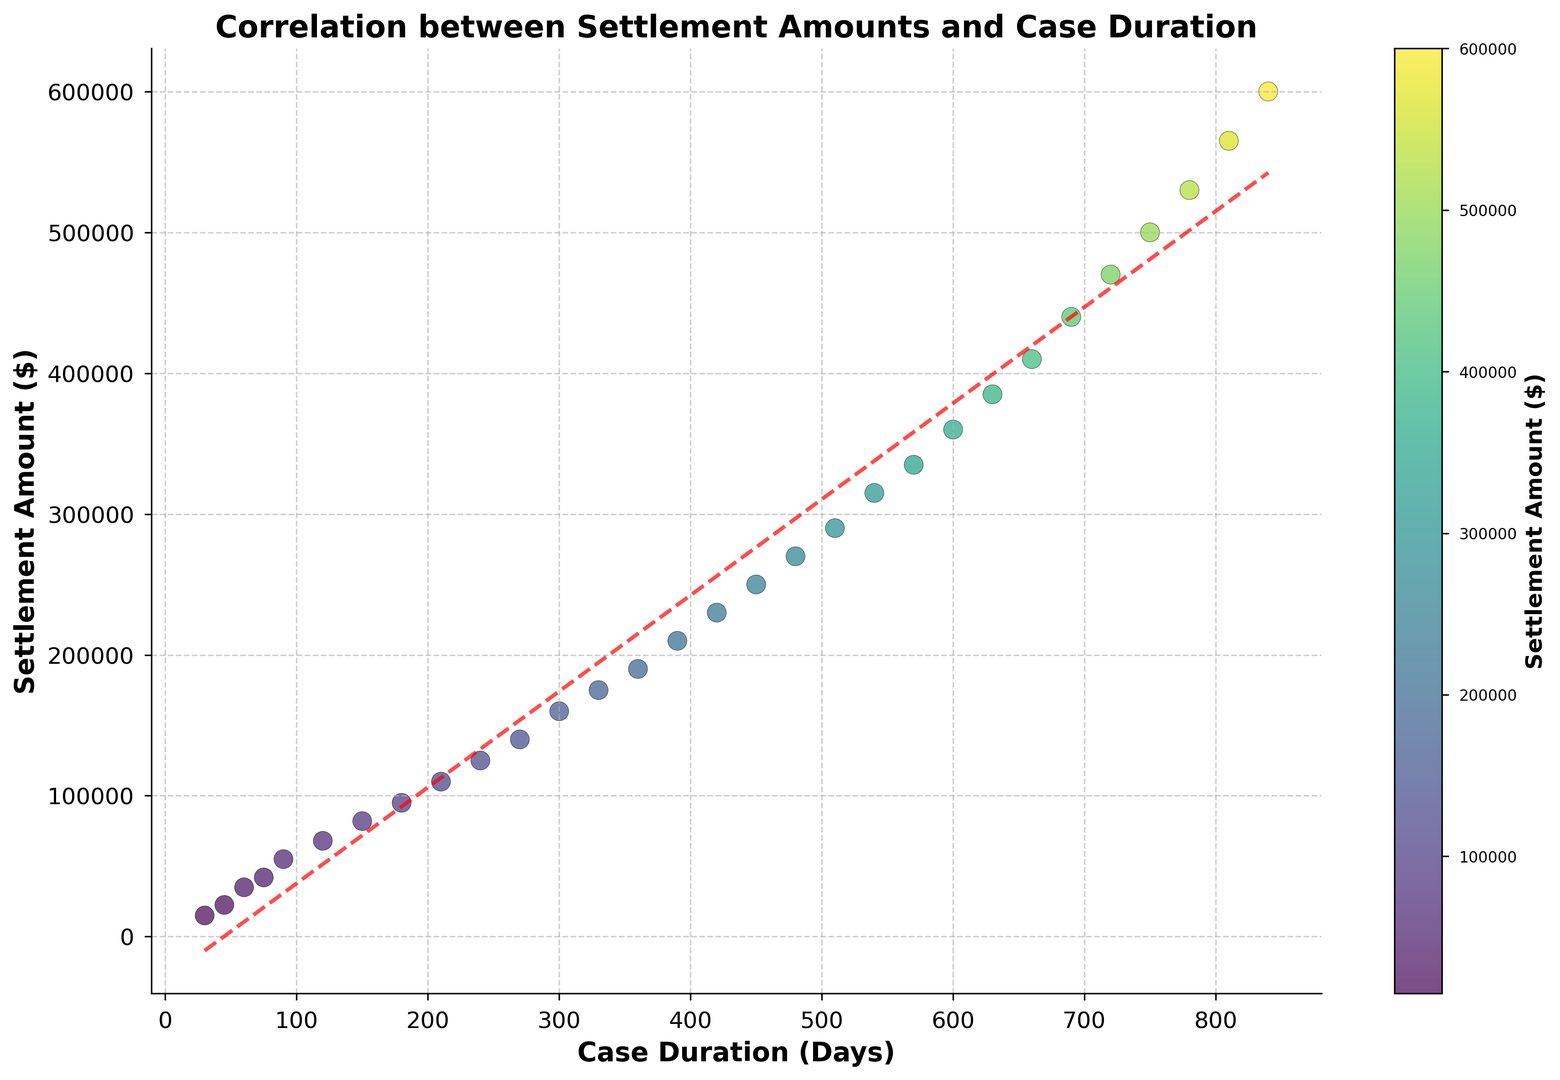What is the general trend shown by the scatter plot? The scatter plot shows a positive correlation between case duration and settlement amount; as the number of days increases, the settlement amount generally increases.
Answer: Positive correlation Which case duration had the highest settlement amount? Find the highest point on the y-axis, then refer to the corresponding x-axis value. The point at $600,000 corresponds to 840 days.
Answer: 840 days How does the settlement amount change as case duration moves from 180 days to 210 days? Compare the y-values at 180 days and 210 days. At 180 days, the amount is $95,000; at 210 days, it is $110,000. The settlement amount increases by $15,000.
Answer: Increases by $15,000 What is the average settlement amount for case durations greater than 500 days? Identify the points where the case duration is greater than 500 days, sum their settlement amounts, then divide by the number of points. The relevant points are (540, 315000), (570, 335000), (600, 360000), (630, 385000), (660, 410000), (690, 440000), (720, 470000), (750, 500000), (780, 530000), (810, 565000), (840, 600000). The sum is 4710000. The number of points is 11. So, the average is 4710000 / 11 = 428181.82.
Answer: $428,181.82 Is there a settlement amount for which two different case durations have the same value? Check for repeat y-values in the scatter plot. There are no pairs of different x-values corresponding to the same y-value in the given data.
Answer: No What is the rate of increase in settlement amount per day between 150 and 180 days? Find the difference in settlement amount and divide by the difference in days. Settlement at 150 days is $82,000, and at 180 days is $95,000. (95,000 - 82,000) / (180 - 150) = 13,000 / 30 = 433.33. So, the rate is $433.33 per day.
Answer: $433.33 per day What color represents higher settlement amounts on the plot? Higher settlement amounts are indicated by brighter yellow colors in the viridis colormap used.
Answer: Brighter yellow Based on the trend line, what is the approximate settlement amount for a case duration of 400 days? Locate 400 days on the x-axis and find the corresponding y-value on the trend line (red dashed line). It approximates to around $220,000.
Answer: $220,000 What is the settlement amount difference between 75 days and 300 days? Subtract the settlement amount at 75 days from that at 300 days. Settlement at 75 days is $42,000, and at 300 days is $160,000. So, 160,000 - 42,000 = 118,000.
Answer: $118,000 How many cases have a duration of less than 200 days? Count the number of points with x-values less than 200 days. There are 7 points that meet this criterion.
Answer: 7 